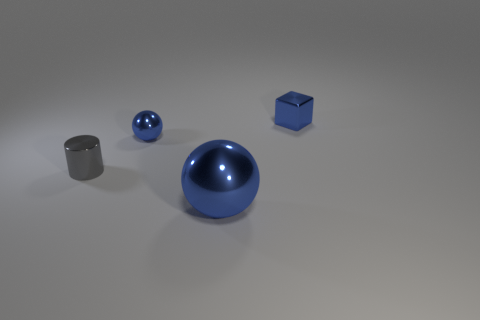Add 4 gray metallic cylinders. How many objects exist? 8 Subtract all blocks. How many objects are left? 3 Add 3 blue matte spheres. How many blue matte spheres exist? 3 Subtract 0 red blocks. How many objects are left? 4 Subtract all large blue metallic objects. Subtract all blocks. How many objects are left? 2 Add 2 tiny blue metal things. How many tiny blue metal things are left? 4 